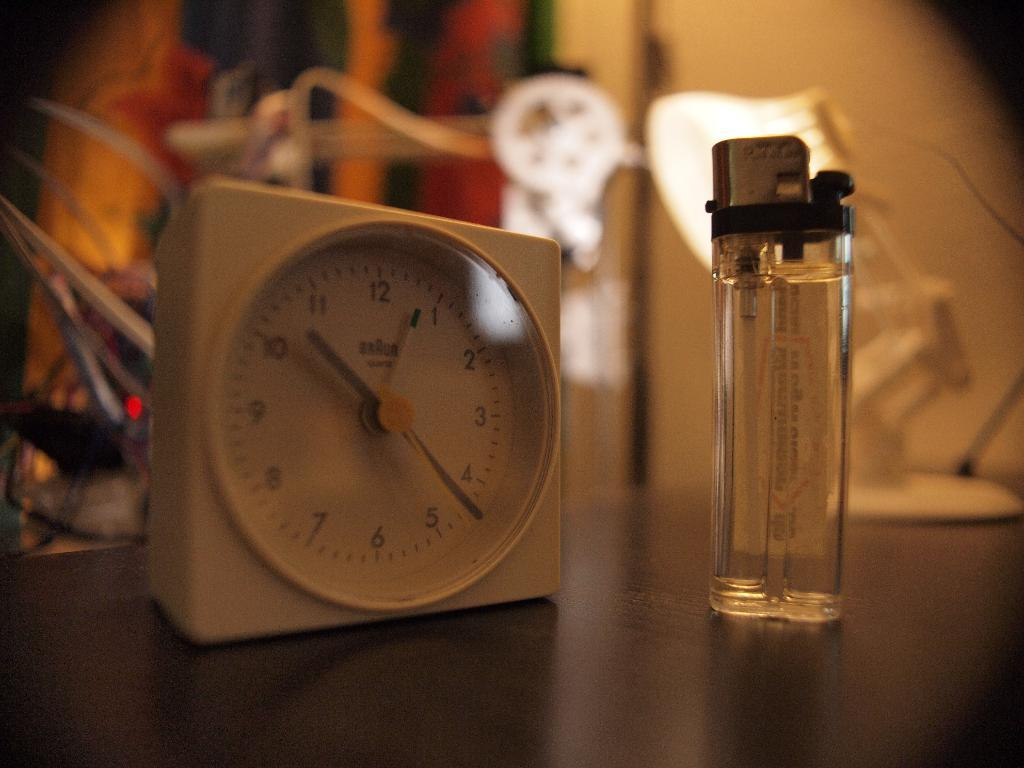<image>
Write a terse but informative summary of the picture. A small clock with the small hand between the 10 and 11. 